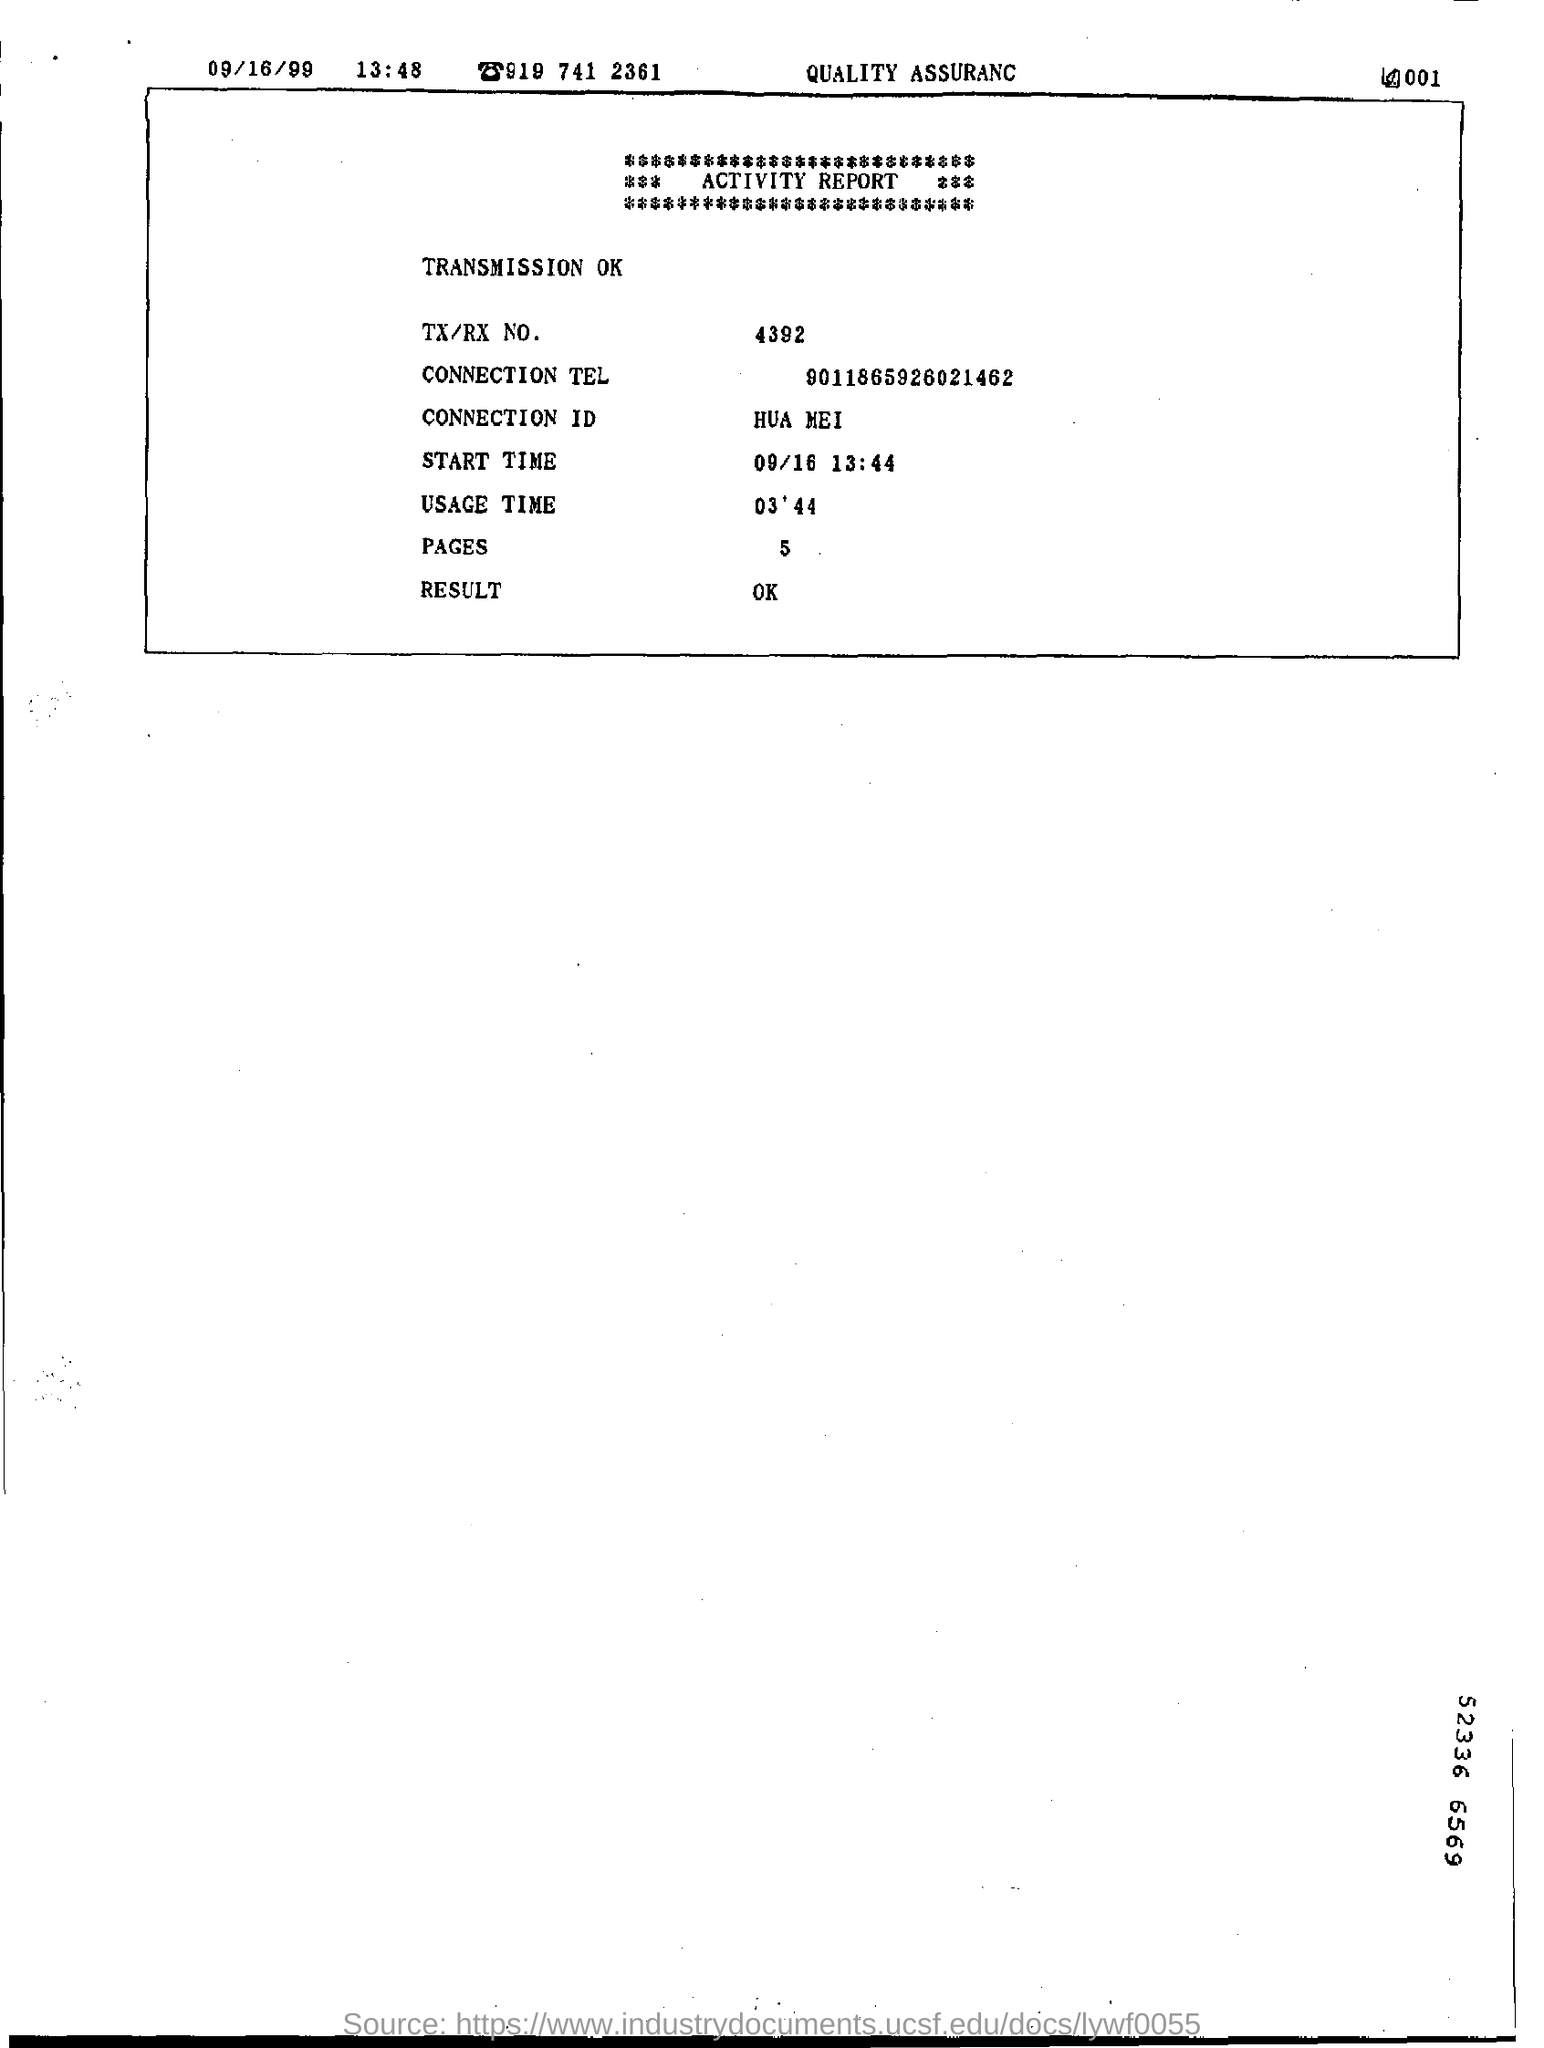Specify some key components in this picture. The document contains five pages. 